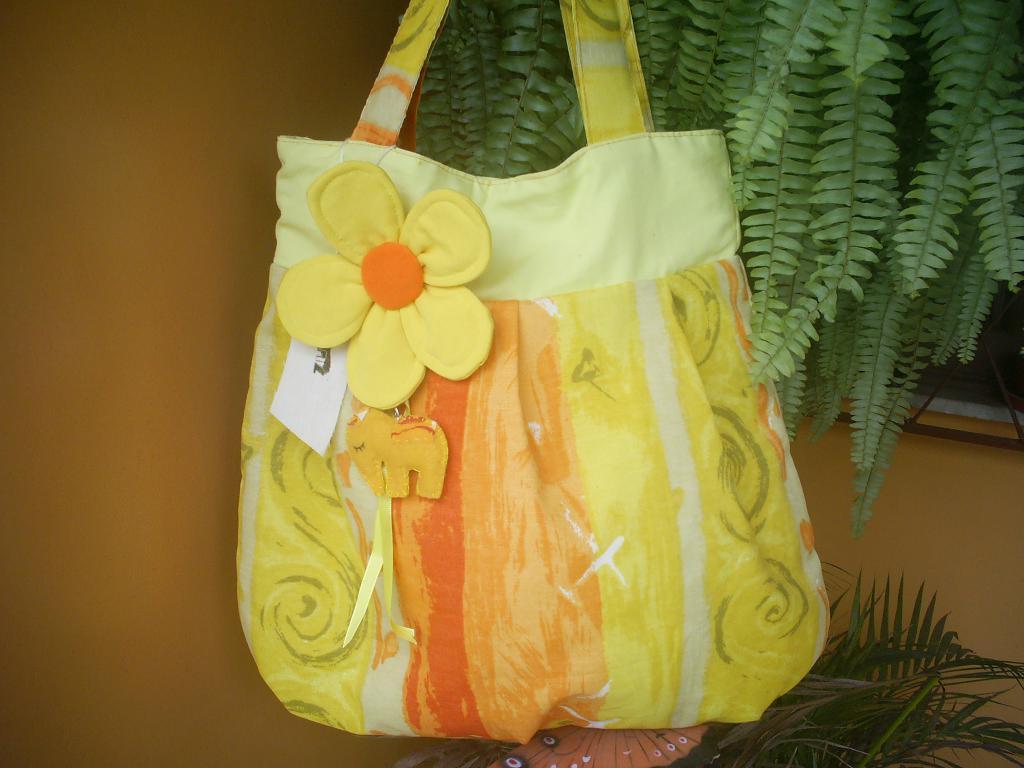How would you summarize this image in a sentence or two? In this image, a handbag is visible made up of cloth. In the bottom right, a house plant is visible. And in the top right, plants are visible. In the left, a wall is visible of light brown in color. This image is taken outside the house during day time. 